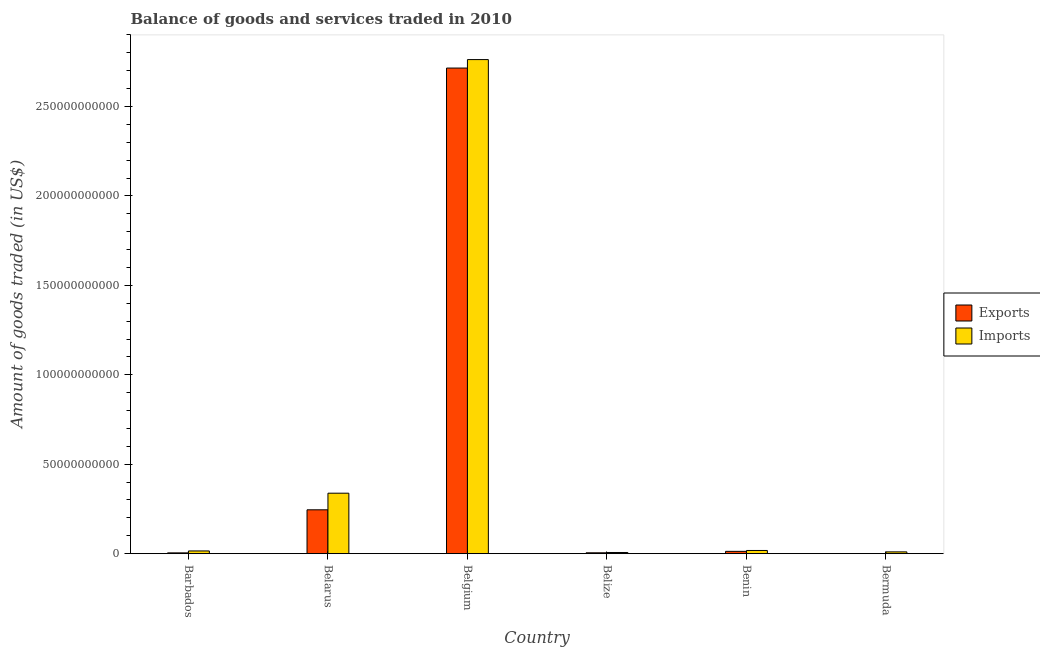How many different coloured bars are there?
Provide a short and direct response. 2. How many bars are there on the 5th tick from the left?
Give a very brief answer. 2. How many bars are there on the 5th tick from the right?
Ensure brevity in your answer.  2. What is the label of the 1st group of bars from the left?
Keep it short and to the point. Barbados. What is the amount of goods exported in Belarus?
Give a very brief answer. 2.45e+1. Across all countries, what is the maximum amount of goods imported?
Provide a short and direct response. 2.76e+11. Across all countries, what is the minimum amount of goods imported?
Give a very brief answer. 6.47e+08. In which country was the amount of goods imported minimum?
Offer a very short reply. Belize. What is the total amount of goods imported in the graph?
Keep it short and to the point. 3.15e+11. What is the difference between the amount of goods imported in Barbados and that in Belize?
Offer a terse response. 8.59e+08. What is the difference between the amount of goods exported in Belgium and the amount of goods imported in Belize?
Offer a terse response. 2.71e+11. What is the average amount of goods exported per country?
Your answer should be compact. 4.97e+1. What is the difference between the amount of goods exported and amount of goods imported in Barbados?
Keep it short and to the point. -1.08e+09. In how many countries, is the amount of goods imported greater than 50000000000 US$?
Provide a short and direct response. 1. What is the ratio of the amount of goods exported in Belgium to that in Belize?
Offer a very short reply. 570.66. What is the difference between the highest and the second highest amount of goods imported?
Your answer should be very brief. 2.42e+11. What is the difference between the highest and the lowest amount of goods exported?
Offer a terse response. 2.71e+11. Is the sum of the amount of goods imported in Belarus and Belize greater than the maximum amount of goods exported across all countries?
Your response must be concise. No. What does the 2nd bar from the left in Belarus represents?
Provide a short and direct response. Imports. What does the 1st bar from the right in Barbados represents?
Your response must be concise. Imports. How many countries are there in the graph?
Make the answer very short. 6. Are the values on the major ticks of Y-axis written in scientific E-notation?
Offer a very short reply. No. Does the graph contain any zero values?
Give a very brief answer. No. How many legend labels are there?
Give a very brief answer. 2. What is the title of the graph?
Ensure brevity in your answer.  Balance of goods and services traded in 2010. What is the label or title of the X-axis?
Your answer should be compact. Country. What is the label or title of the Y-axis?
Your answer should be very brief. Amount of goods traded (in US$). What is the Amount of goods traded (in US$) of Exports in Barbados?
Make the answer very short. 4.31e+08. What is the Amount of goods traded (in US$) of Imports in Barbados?
Keep it short and to the point. 1.51e+09. What is the Amount of goods traded (in US$) in Exports in Belarus?
Ensure brevity in your answer.  2.45e+1. What is the Amount of goods traded (in US$) of Imports in Belarus?
Your answer should be compact. 3.38e+1. What is the Amount of goods traded (in US$) in Exports in Belgium?
Ensure brevity in your answer.  2.71e+11. What is the Amount of goods traded (in US$) in Imports in Belgium?
Your answer should be very brief. 2.76e+11. What is the Amount of goods traded (in US$) of Exports in Belize?
Offer a very short reply. 4.76e+08. What is the Amount of goods traded (in US$) of Imports in Belize?
Provide a short and direct response. 6.47e+08. What is the Amount of goods traded (in US$) of Exports in Benin?
Make the answer very short. 1.28e+09. What is the Amount of goods traded (in US$) in Imports in Benin?
Your answer should be very brief. 1.78e+09. What is the Amount of goods traded (in US$) in Exports in Bermuda?
Keep it short and to the point. 1.47e+07. What is the Amount of goods traded (in US$) in Imports in Bermuda?
Give a very brief answer. 9.88e+08. Across all countries, what is the maximum Amount of goods traded (in US$) of Exports?
Keep it short and to the point. 2.71e+11. Across all countries, what is the maximum Amount of goods traded (in US$) in Imports?
Give a very brief answer. 2.76e+11. Across all countries, what is the minimum Amount of goods traded (in US$) in Exports?
Your answer should be very brief. 1.47e+07. Across all countries, what is the minimum Amount of goods traded (in US$) of Imports?
Offer a very short reply. 6.47e+08. What is the total Amount of goods traded (in US$) in Exports in the graph?
Offer a terse response. 2.98e+11. What is the total Amount of goods traded (in US$) of Imports in the graph?
Give a very brief answer. 3.15e+11. What is the difference between the Amount of goods traded (in US$) in Exports in Barbados and that in Belarus?
Offer a very short reply. -2.41e+1. What is the difference between the Amount of goods traded (in US$) of Imports in Barbados and that in Belarus?
Your response must be concise. -3.23e+1. What is the difference between the Amount of goods traded (in US$) in Exports in Barbados and that in Belgium?
Your answer should be compact. -2.71e+11. What is the difference between the Amount of goods traded (in US$) in Imports in Barbados and that in Belgium?
Make the answer very short. -2.75e+11. What is the difference between the Amount of goods traded (in US$) of Exports in Barbados and that in Belize?
Your answer should be compact. -4.51e+07. What is the difference between the Amount of goods traded (in US$) in Imports in Barbados and that in Belize?
Offer a terse response. 8.59e+08. What is the difference between the Amount of goods traded (in US$) of Exports in Barbados and that in Benin?
Ensure brevity in your answer.  -8.51e+08. What is the difference between the Amount of goods traded (in US$) in Imports in Barbados and that in Benin?
Make the answer very short. -2.69e+08. What is the difference between the Amount of goods traded (in US$) in Exports in Barbados and that in Bermuda?
Your response must be concise. 4.16e+08. What is the difference between the Amount of goods traded (in US$) in Imports in Barbados and that in Bermuda?
Provide a short and direct response. 5.19e+08. What is the difference between the Amount of goods traded (in US$) in Exports in Belarus and that in Belgium?
Your answer should be very brief. -2.47e+11. What is the difference between the Amount of goods traded (in US$) in Imports in Belarus and that in Belgium?
Your response must be concise. -2.42e+11. What is the difference between the Amount of goods traded (in US$) of Exports in Belarus and that in Belize?
Provide a succinct answer. 2.40e+1. What is the difference between the Amount of goods traded (in US$) in Imports in Belarus and that in Belize?
Your answer should be very brief. 3.31e+1. What is the difference between the Amount of goods traded (in US$) of Exports in Belarus and that in Benin?
Keep it short and to the point. 2.32e+1. What is the difference between the Amount of goods traded (in US$) in Imports in Belarus and that in Benin?
Ensure brevity in your answer.  3.20e+1. What is the difference between the Amount of goods traded (in US$) in Exports in Belarus and that in Bermuda?
Ensure brevity in your answer.  2.45e+1. What is the difference between the Amount of goods traded (in US$) of Imports in Belarus and that in Bermuda?
Make the answer very short. 3.28e+1. What is the difference between the Amount of goods traded (in US$) of Exports in Belgium and that in Belize?
Make the answer very short. 2.71e+11. What is the difference between the Amount of goods traded (in US$) in Imports in Belgium and that in Belize?
Your response must be concise. 2.76e+11. What is the difference between the Amount of goods traded (in US$) in Exports in Belgium and that in Benin?
Offer a very short reply. 2.70e+11. What is the difference between the Amount of goods traded (in US$) of Imports in Belgium and that in Benin?
Your response must be concise. 2.74e+11. What is the difference between the Amount of goods traded (in US$) in Exports in Belgium and that in Bermuda?
Keep it short and to the point. 2.71e+11. What is the difference between the Amount of goods traded (in US$) of Imports in Belgium and that in Bermuda?
Make the answer very short. 2.75e+11. What is the difference between the Amount of goods traded (in US$) in Exports in Belize and that in Benin?
Provide a short and direct response. -8.06e+08. What is the difference between the Amount of goods traded (in US$) in Imports in Belize and that in Benin?
Offer a very short reply. -1.13e+09. What is the difference between the Amount of goods traded (in US$) of Exports in Belize and that in Bermuda?
Your answer should be very brief. 4.61e+08. What is the difference between the Amount of goods traded (in US$) of Imports in Belize and that in Bermuda?
Ensure brevity in your answer.  -3.41e+08. What is the difference between the Amount of goods traded (in US$) in Exports in Benin and that in Bermuda?
Ensure brevity in your answer.  1.27e+09. What is the difference between the Amount of goods traded (in US$) in Imports in Benin and that in Bermuda?
Make the answer very short. 7.87e+08. What is the difference between the Amount of goods traded (in US$) of Exports in Barbados and the Amount of goods traded (in US$) of Imports in Belarus?
Your response must be concise. -3.34e+1. What is the difference between the Amount of goods traded (in US$) of Exports in Barbados and the Amount of goods traded (in US$) of Imports in Belgium?
Provide a short and direct response. -2.76e+11. What is the difference between the Amount of goods traded (in US$) in Exports in Barbados and the Amount of goods traded (in US$) in Imports in Belize?
Your answer should be very brief. -2.17e+08. What is the difference between the Amount of goods traded (in US$) in Exports in Barbados and the Amount of goods traded (in US$) in Imports in Benin?
Give a very brief answer. -1.34e+09. What is the difference between the Amount of goods traded (in US$) in Exports in Barbados and the Amount of goods traded (in US$) in Imports in Bermuda?
Give a very brief answer. -5.57e+08. What is the difference between the Amount of goods traded (in US$) of Exports in Belarus and the Amount of goods traded (in US$) of Imports in Belgium?
Provide a short and direct response. -2.52e+11. What is the difference between the Amount of goods traded (in US$) in Exports in Belarus and the Amount of goods traded (in US$) in Imports in Belize?
Ensure brevity in your answer.  2.39e+1. What is the difference between the Amount of goods traded (in US$) in Exports in Belarus and the Amount of goods traded (in US$) in Imports in Benin?
Make the answer very short. 2.27e+1. What is the difference between the Amount of goods traded (in US$) in Exports in Belarus and the Amount of goods traded (in US$) in Imports in Bermuda?
Offer a terse response. 2.35e+1. What is the difference between the Amount of goods traded (in US$) of Exports in Belgium and the Amount of goods traded (in US$) of Imports in Belize?
Your answer should be very brief. 2.71e+11. What is the difference between the Amount of goods traded (in US$) of Exports in Belgium and the Amount of goods traded (in US$) of Imports in Benin?
Ensure brevity in your answer.  2.70e+11. What is the difference between the Amount of goods traded (in US$) in Exports in Belgium and the Amount of goods traded (in US$) in Imports in Bermuda?
Your response must be concise. 2.70e+11. What is the difference between the Amount of goods traded (in US$) of Exports in Belize and the Amount of goods traded (in US$) of Imports in Benin?
Your answer should be very brief. -1.30e+09. What is the difference between the Amount of goods traded (in US$) of Exports in Belize and the Amount of goods traded (in US$) of Imports in Bermuda?
Keep it short and to the point. -5.12e+08. What is the difference between the Amount of goods traded (in US$) in Exports in Benin and the Amount of goods traded (in US$) in Imports in Bermuda?
Ensure brevity in your answer.  2.93e+08. What is the average Amount of goods traded (in US$) of Exports per country?
Make the answer very short. 4.97e+1. What is the average Amount of goods traded (in US$) in Imports per country?
Your answer should be compact. 5.25e+1. What is the difference between the Amount of goods traded (in US$) of Exports and Amount of goods traded (in US$) of Imports in Barbados?
Your response must be concise. -1.08e+09. What is the difference between the Amount of goods traded (in US$) of Exports and Amount of goods traded (in US$) of Imports in Belarus?
Your answer should be very brief. -9.29e+09. What is the difference between the Amount of goods traded (in US$) in Exports and Amount of goods traded (in US$) in Imports in Belgium?
Your answer should be very brief. -4.74e+09. What is the difference between the Amount of goods traded (in US$) in Exports and Amount of goods traded (in US$) in Imports in Belize?
Ensure brevity in your answer.  -1.71e+08. What is the difference between the Amount of goods traded (in US$) of Exports and Amount of goods traded (in US$) of Imports in Benin?
Your response must be concise. -4.94e+08. What is the difference between the Amount of goods traded (in US$) in Exports and Amount of goods traded (in US$) in Imports in Bermuda?
Offer a very short reply. -9.73e+08. What is the ratio of the Amount of goods traded (in US$) of Exports in Barbados to that in Belarus?
Offer a very short reply. 0.02. What is the ratio of the Amount of goods traded (in US$) in Imports in Barbados to that in Belarus?
Give a very brief answer. 0.04. What is the ratio of the Amount of goods traded (in US$) in Exports in Barbados to that in Belgium?
Keep it short and to the point. 0. What is the ratio of the Amount of goods traded (in US$) of Imports in Barbados to that in Belgium?
Give a very brief answer. 0.01. What is the ratio of the Amount of goods traded (in US$) in Exports in Barbados to that in Belize?
Offer a terse response. 0.91. What is the ratio of the Amount of goods traded (in US$) in Imports in Barbados to that in Belize?
Provide a succinct answer. 2.33. What is the ratio of the Amount of goods traded (in US$) of Exports in Barbados to that in Benin?
Keep it short and to the point. 0.34. What is the ratio of the Amount of goods traded (in US$) of Imports in Barbados to that in Benin?
Give a very brief answer. 0.85. What is the ratio of the Amount of goods traded (in US$) in Exports in Barbados to that in Bermuda?
Offer a very short reply. 29.33. What is the ratio of the Amount of goods traded (in US$) in Imports in Barbados to that in Bermuda?
Provide a succinct answer. 1.52. What is the ratio of the Amount of goods traded (in US$) of Exports in Belarus to that in Belgium?
Ensure brevity in your answer.  0.09. What is the ratio of the Amount of goods traded (in US$) in Imports in Belarus to that in Belgium?
Your answer should be very brief. 0.12. What is the ratio of the Amount of goods traded (in US$) in Exports in Belarus to that in Belize?
Your answer should be very brief. 51.51. What is the ratio of the Amount of goods traded (in US$) of Imports in Belarus to that in Belize?
Your answer should be very brief. 52.22. What is the ratio of the Amount of goods traded (in US$) in Exports in Belarus to that in Benin?
Make the answer very short. 19.12. What is the ratio of the Amount of goods traded (in US$) in Imports in Belarus to that in Benin?
Provide a short and direct response. 19.04. What is the ratio of the Amount of goods traded (in US$) in Exports in Belarus to that in Bermuda?
Keep it short and to the point. 1668.89. What is the ratio of the Amount of goods traded (in US$) of Imports in Belarus to that in Bermuda?
Give a very brief answer. 34.2. What is the ratio of the Amount of goods traded (in US$) in Exports in Belgium to that in Belize?
Your answer should be very brief. 570.66. What is the ratio of the Amount of goods traded (in US$) of Imports in Belgium to that in Belize?
Offer a terse response. 426.78. What is the ratio of the Amount of goods traded (in US$) of Exports in Belgium to that in Benin?
Offer a terse response. 211.84. What is the ratio of the Amount of goods traded (in US$) of Imports in Belgium to that in Benin?
Provide a succinct answer. 155.6. What is the ratio of the Amount of goods traded (in US$) in Exports in Belgium to that in Bermuda?
Keep it short and to the point. 1.85e+04. What is the ratio of the Amount of goods traded (in US$) in Imports in Belgium to that in Bermuda?
Your response must be concise. 279.56. What is the ratio of the Amount of goods traded (in US$) in Exports in Belize to that in Benin?
Your answer should be compact. 0.37. What is the ratio of the Amount of goods traded (in US$) of Imports in Belize to that in Benin?
Make the answer very short. 0.36. What is the ratio of the Amount of goods traded (in US$) in Exports in Belize to that in Bermuda?
Offer a very short reply. 32.4. What is the ratio of the Amount of goods traded (in US$) of Imports in Belize to that in Bermuda?
Keep it short and to the point. 0.66. What is the ratio of the Amount of goods traded (in US$) of Exports in Benin to that in Bermuda?
Provide a short and direct response. 87.27. What is the ratio of the Amount of goods traded (in US$) in Imports in Benin to that in Bermuda?
Your answer should be very brief. 1.8. What is the difference between the highest and the second highest Amount of goods traded (in US$) in Exports?
Your response must be concise. 2.47e+11. What is the difference between the highest and the second highest Amount of goods traded (in US$) in Imports?
Your answer should be compact. 2.42e+11. What is the difference between the highest and the lowest Amount of goods traded (in US$) of Exports?
Give a very brief answer. 2.71e+11. What is the difference between the highest and the lowest Amount of goods traded (in US$) in Imports?
Your answer should be compact. 2.76e+11. 